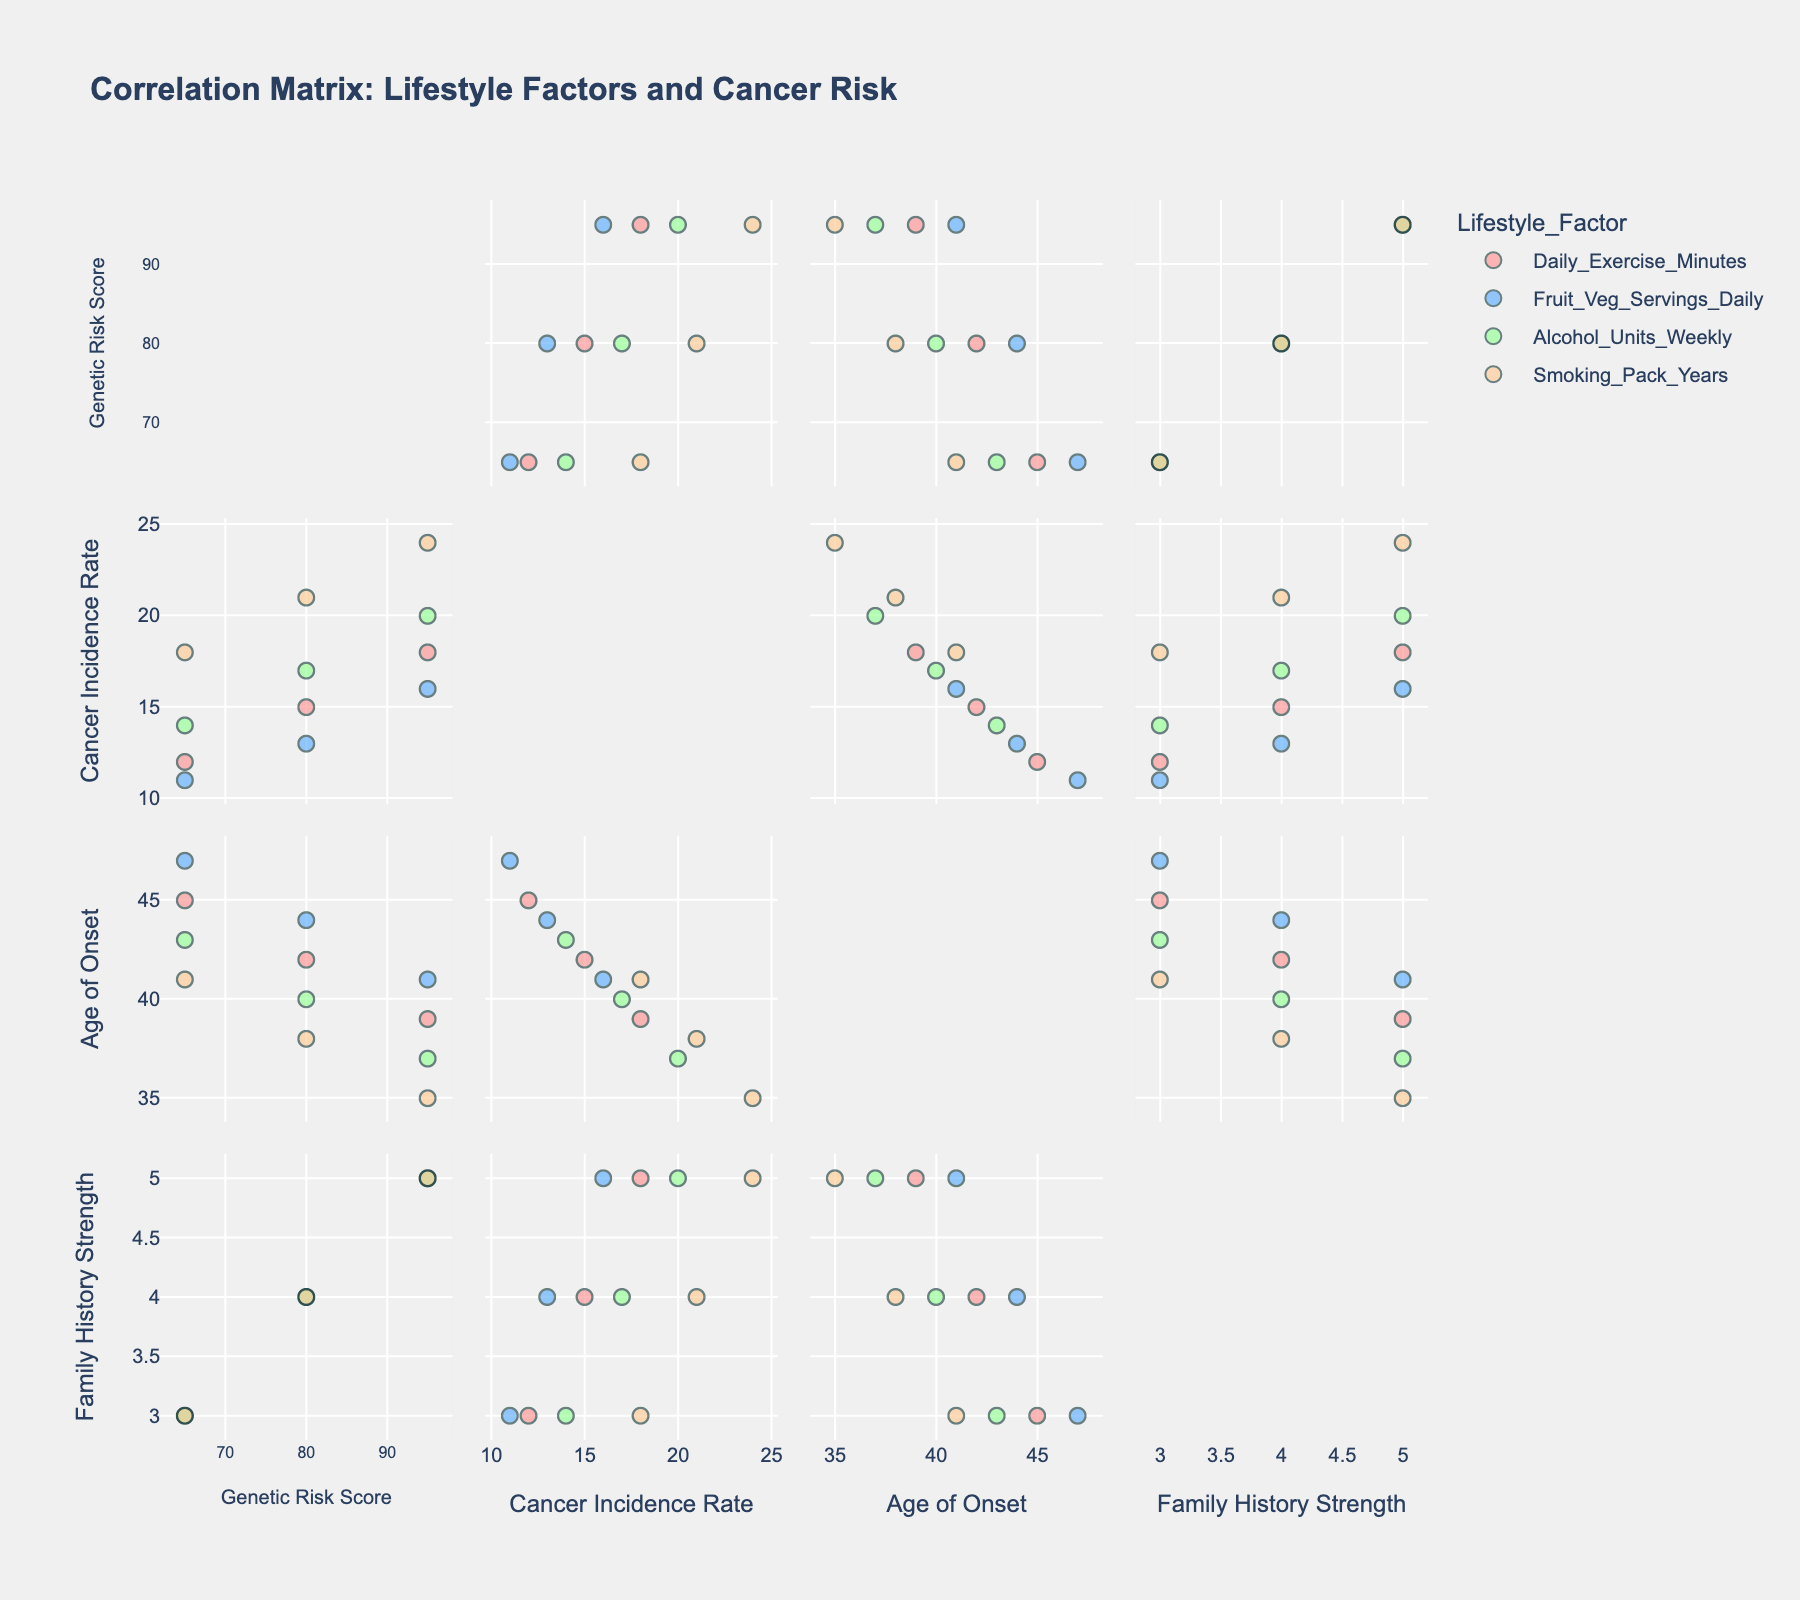What is the title of the figure? The title is displayed at the top of the figure and reads "Workplace Accommodations and Job Retention for Employees with Learning Disabilities".
Answer: Workplace Accommodations and Job Retention for Employees with Learning Disabilities How many data points are there in the Accommodations vs Retention Rate scatter plot? By counting the number of markers (points) on the scatter plot on the left side of the figure, we can see each company is represented as one data point.
Answer: 20 What is the highest retention rate and which company does it correspond to? By looking at the y-axis and identifying the point with the highest value on the Accommodations vs Retention Rate scatter plot, we can see the highest point is at 91%, corresponding to Apple.
Answer: 91%, Apple Is there a trend between the number of accommodations provided and the retention rate? The trend line in red suggests an overall positive relationship, indicating that as the number of accommodations increases, the retention rate tends to increase.
Answer: Positive relationship Which company with only 1 accommodation has the lowest retention rate? By inspecting the points corresponding to the 'Accommodations' value of 1, we see that McDonald's, with a retention rate of 67%, has the lowest rate among them.
Answer: McDonald's, 67% How does the retention rate of FedEx compare to that of UPS? Both FedEx and UPS are represented in the figure. By comparing their retention rates, we can see FedEx has a retention rate of 72% while UPS has a retention rate of 77%.
Answer: UPS has a higher retention rate Which company is represented by the point in the second subplot at the rank size 15 and what is the retention rate for that company? By identifying the 15th rank on the x-axis of the second subplot and checking the corresponding point, we find it is FedEx with a retention rate of 72%.
Answer: FedEx, 72% If you were to average the retention rates of companies with 3 accommodations, what would it be? First, identify companies with 3 accommodations: Microsoft (82%), Starbucks (79%), Lowe's (78%), UPS (77%), and Subway (80%). Sum these rates (82 + 79 + 78 + 77 + 80 = 396). Then, divide by the number of companies (396/5 = 79.2).
Answer: 79.2% Between Google and Amazon, which company has a higher retention rate? Google has a retention rate of 89%, and Amazon has a retention rate of 86%, as shown by their respective points on the first subplot.
Answer: Google What's the average retention rate for companies that provide 2 accommodations? Identify companies with 2 accommodations: IBM (75%), Target (73%), Home Depot (74%), FedEx (72%), CVS Health (76%), Burger King (71%), and Domino's Pizza (74%). Sum their rates (75 + 73 + 74 + 72 + 76 + 71 + 74 = 515). Divide by the number of companies (515/7 = 73.57).
Answer: 73.57% 